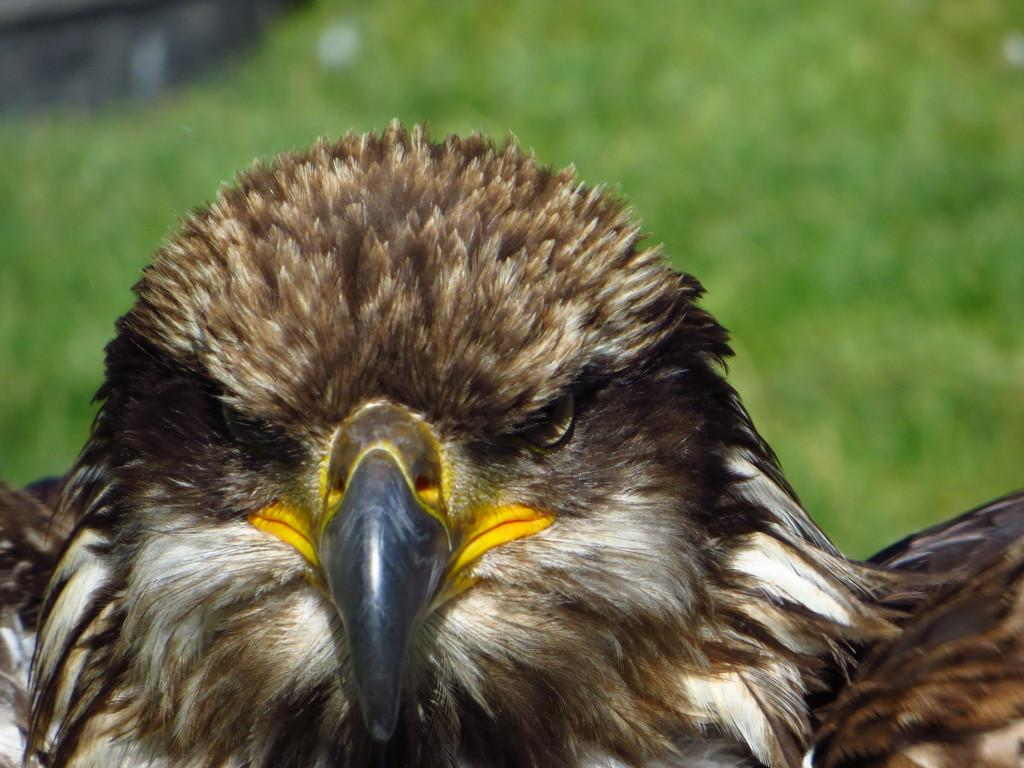What type of animal is in the image? There is a bird in the image. What color is the bird? The bird is brown in color. What can be seen in the background of the image? There is grass in the background of the image. What color is the grass? The grass is green in color. Where is the market located in the image? There is no market present in the image; it features a bird and grass. What type of feast is the bird attending in the image? There is no feast or indication of any event in the image; it simply shows a bird and grass. 